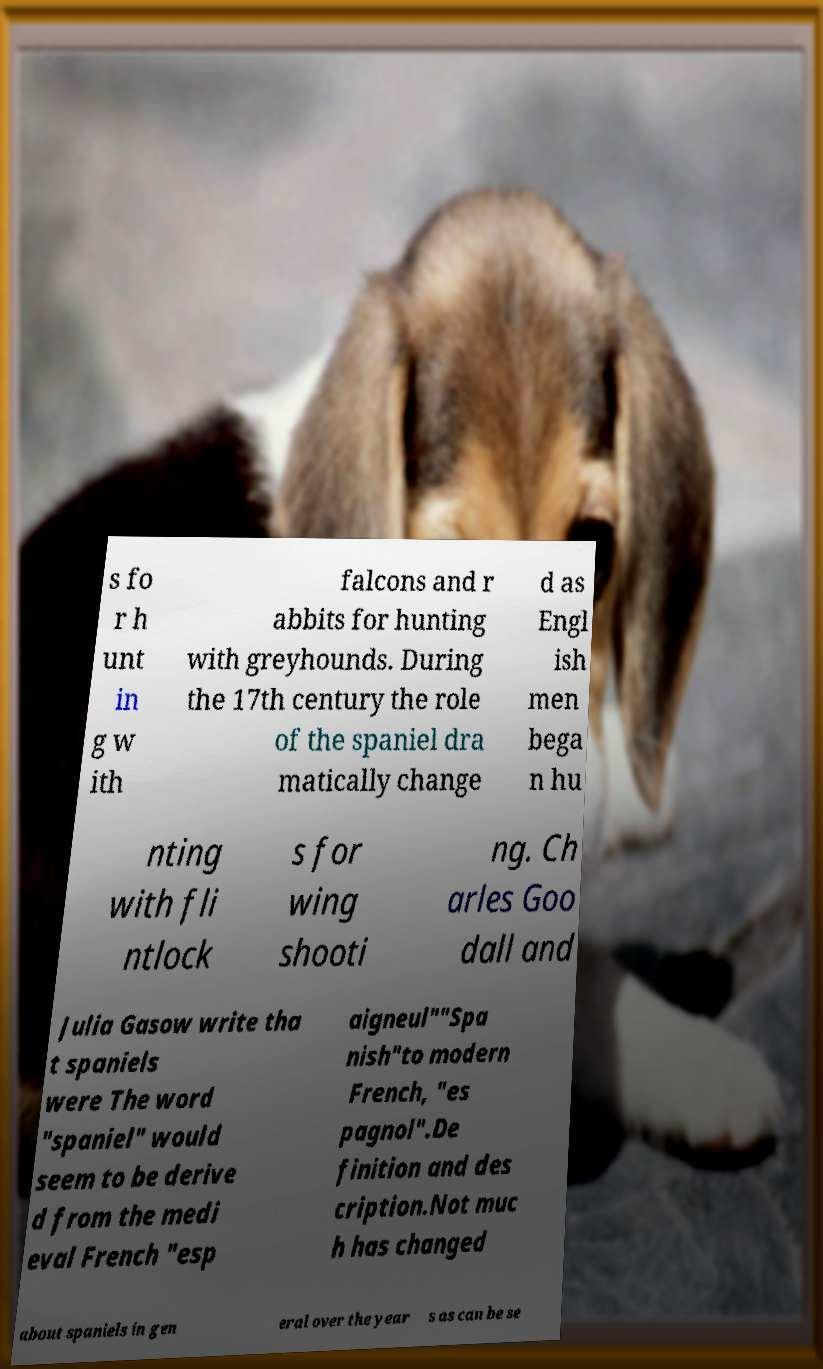Can you accurately transcribe the text from the provided image for me? s fo r h unt in g w ith falcons and r abbits for hunting with greyhounds. During the 17th century the role of the spaniel dra matically change d as Engl ish men bega n hu nting with fli ntlock s for wing shooti ng. Ch arles Goo dall and Julia Gasow write tha t spaniels were The word "spaniel" would seem to be derive d from the medi eval French "esp aigneul""Spa nish"to modern French, "es pagnol".De finition and des cription.Not muc h has changed about spaniels in gen eral over the year s as can be se 